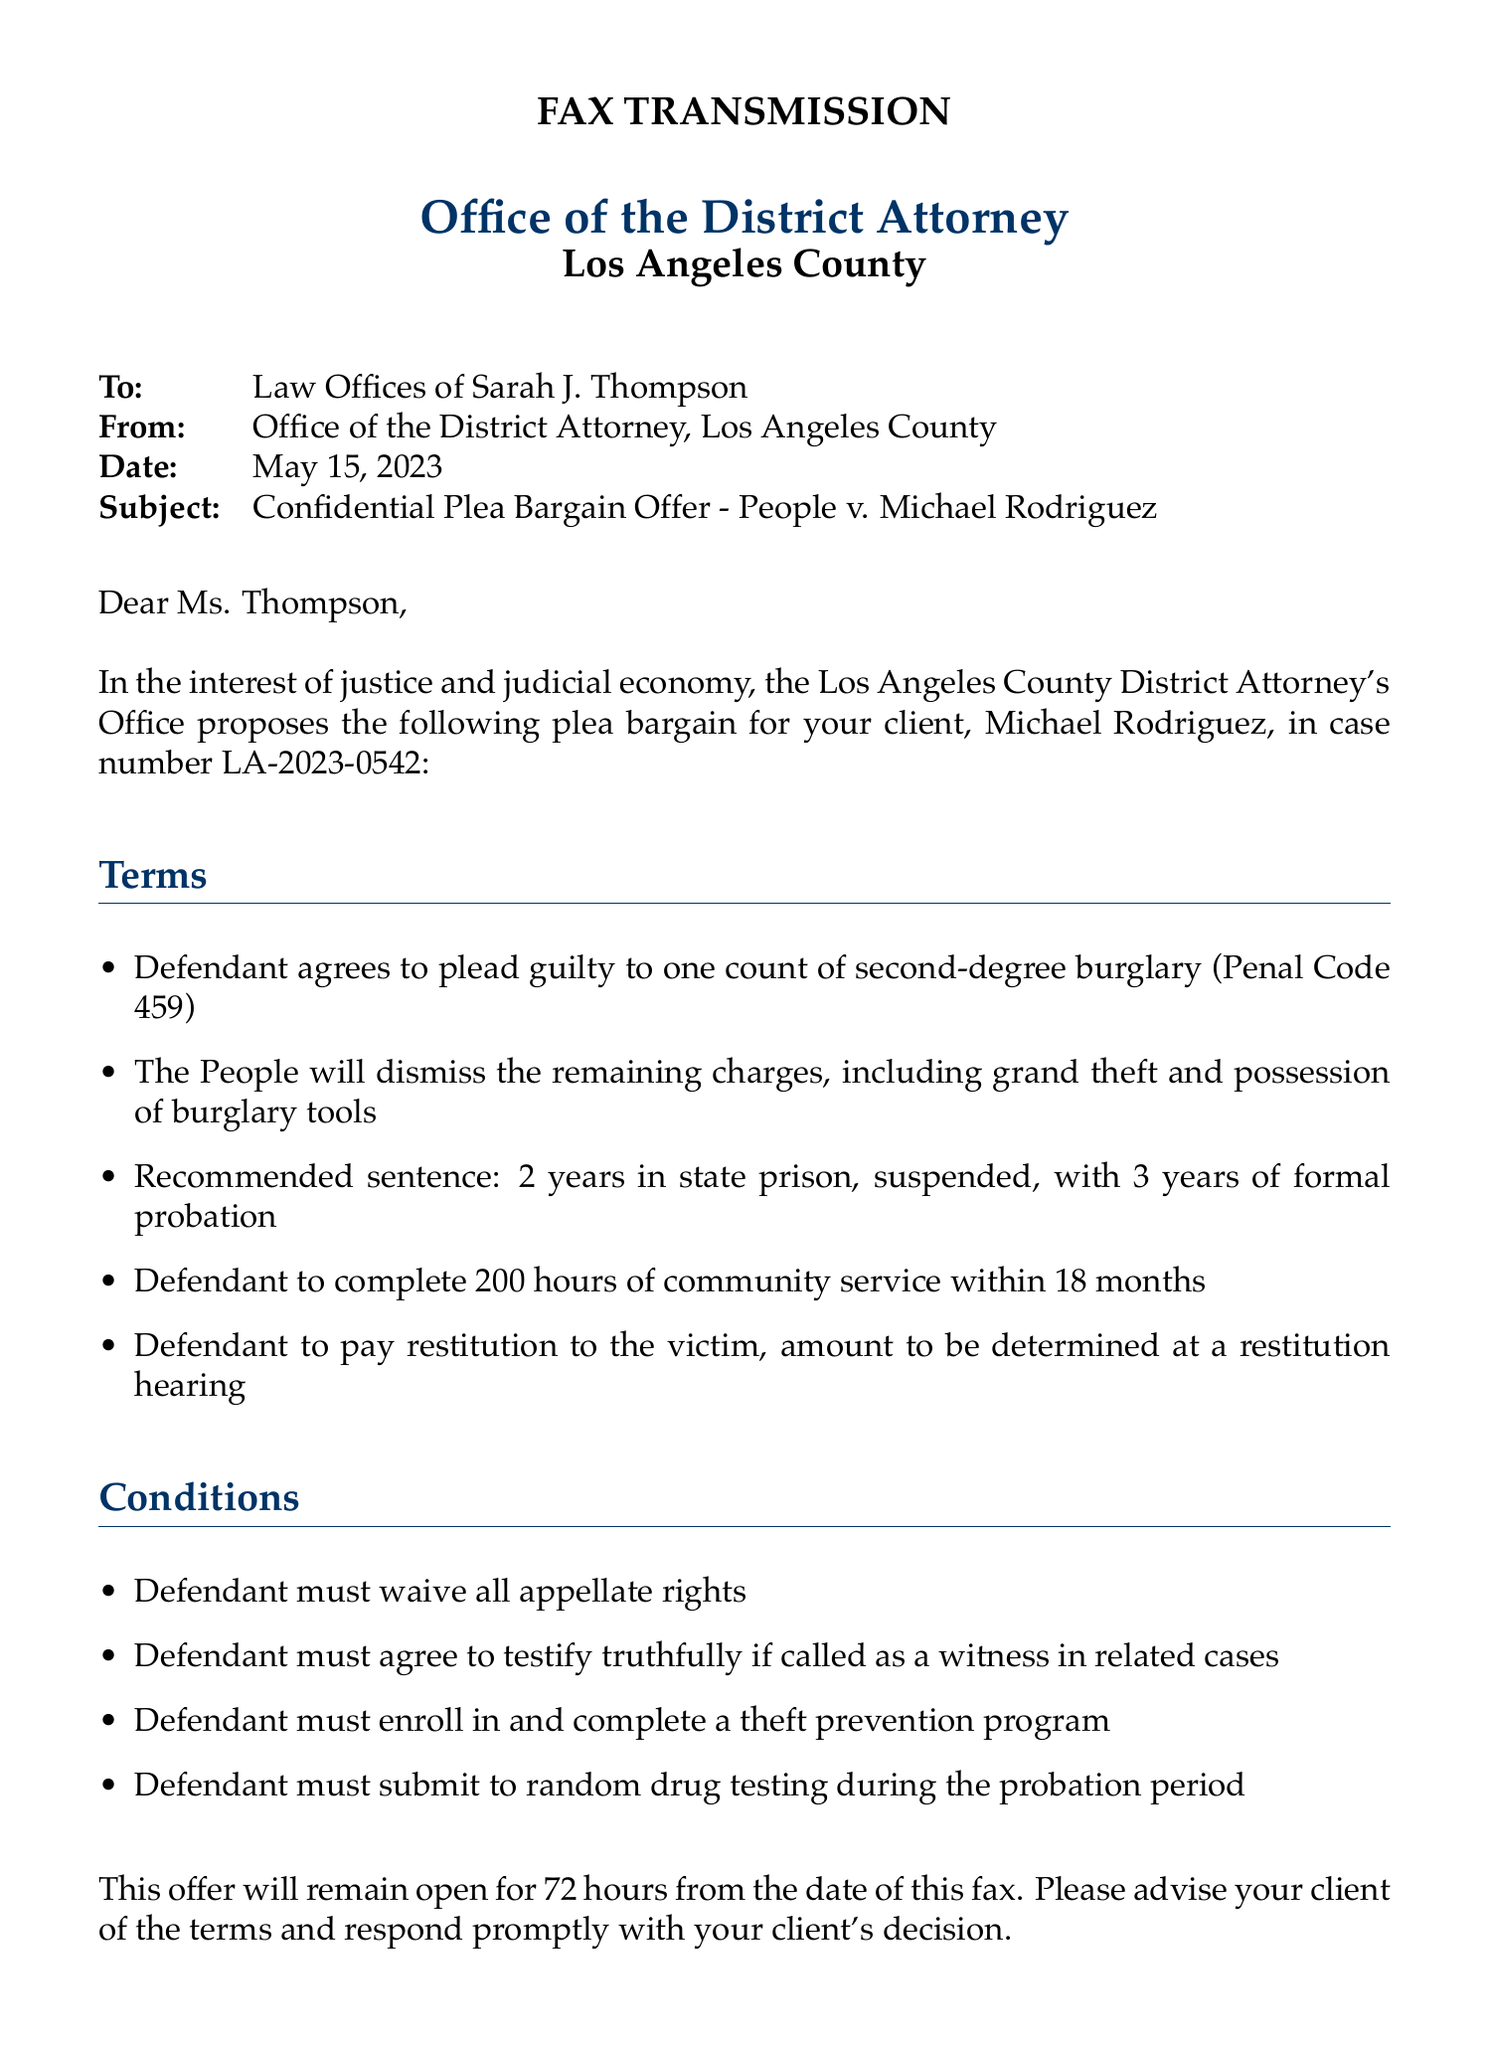What is the date of the fax? The date is specified in the header of the document, listing when the fax was sent.
Answer: May 15, 2023 Who is the recipient of the fax? The document specifically addresses the recipient in the header section.
Answer: Law Offices of Sarah J. Thompson What charge does the defendant agree to plead guilty to? The specific count is clearly mentioned in the terms section of the plea bargain.
Answer: one count of second-degree burglary How long is the recommended sentence? The recommended sentence is listed in the plea bargain terms.
Answer: 2 years How many hours of community service must the defendant complete? The document states the requirement for community service in the terms.
Answer: 200 hours What condition requires cooperation in related cases? This is explicitly mentioned as a condition of the plea bargain.
Answer: testify truthfully if called as a witness What is the time frame for the offer to remain open? The document states a specific time frame following the date of the fax.
Answer: 72 hours Who sent the fax? The sender's name and title are provided at the end of the document.
Answer: James R. Henderson What is the purpose of the confidential communication notice? This notice indicates the sensitivity of the information contained in the fax.
Answer: privileged and confidential information 